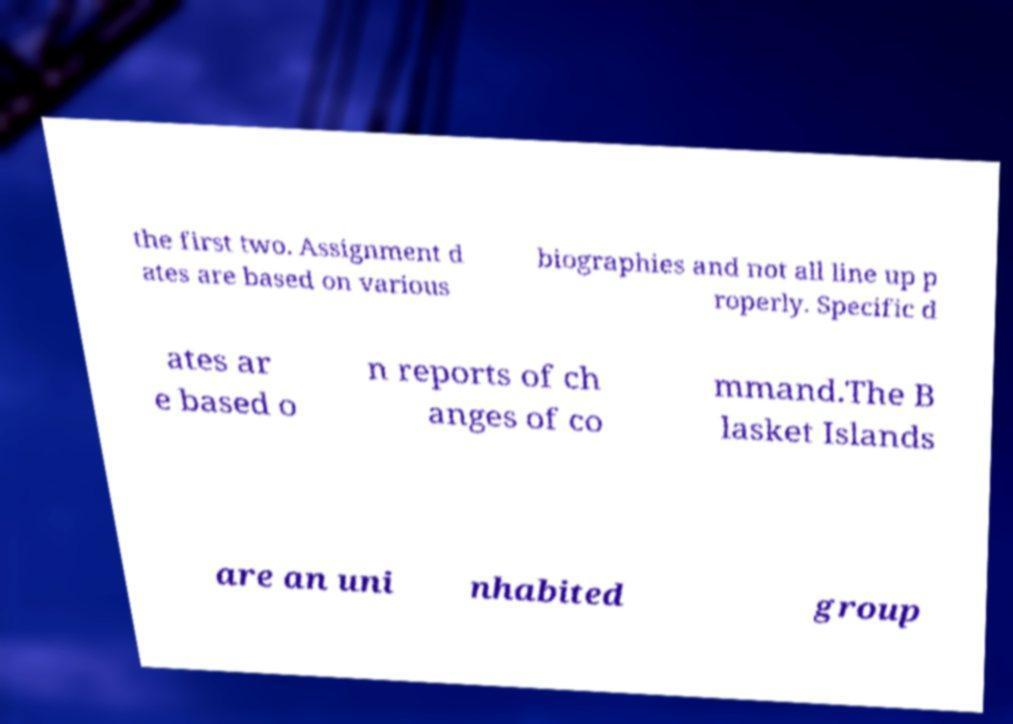Can you read and provide the text displayed in the image?This photo seems to have some interesting text. Can you extract and type it out for me? the first two. Assignment d ates are based on various biographies and not all line up p roperly. Specific d ates ar e based o n reports of ch anges of co mmand.The B lasket Islands are an uni nhabited group 